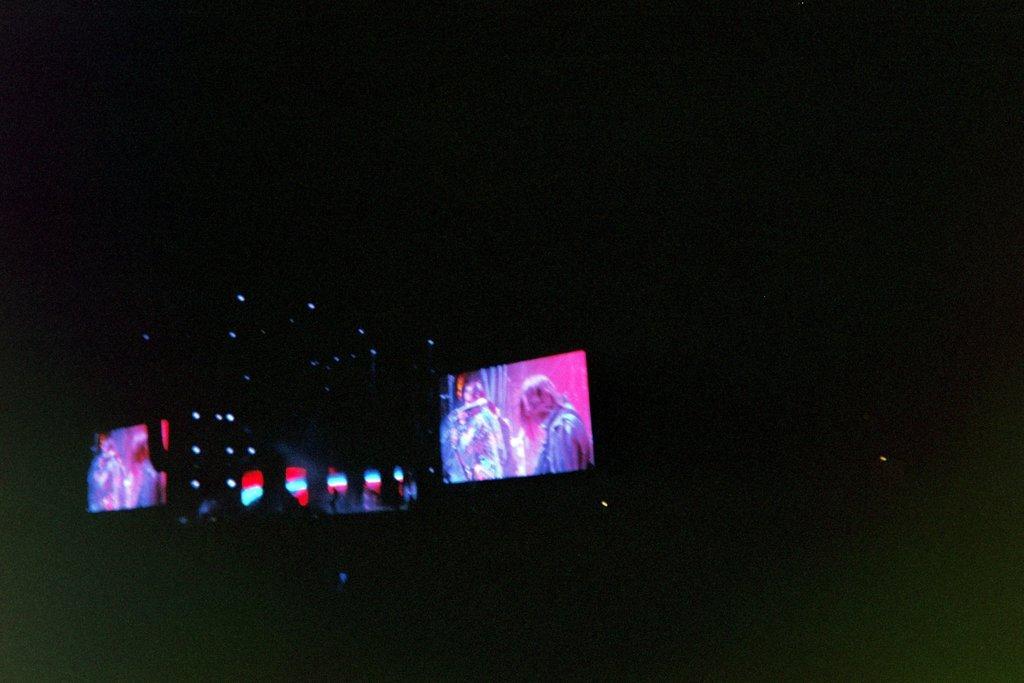In one or two sentences, can you explain what this image depicts? In this picture we can see there are screen and lights. Behind the screen there is a dark background. 